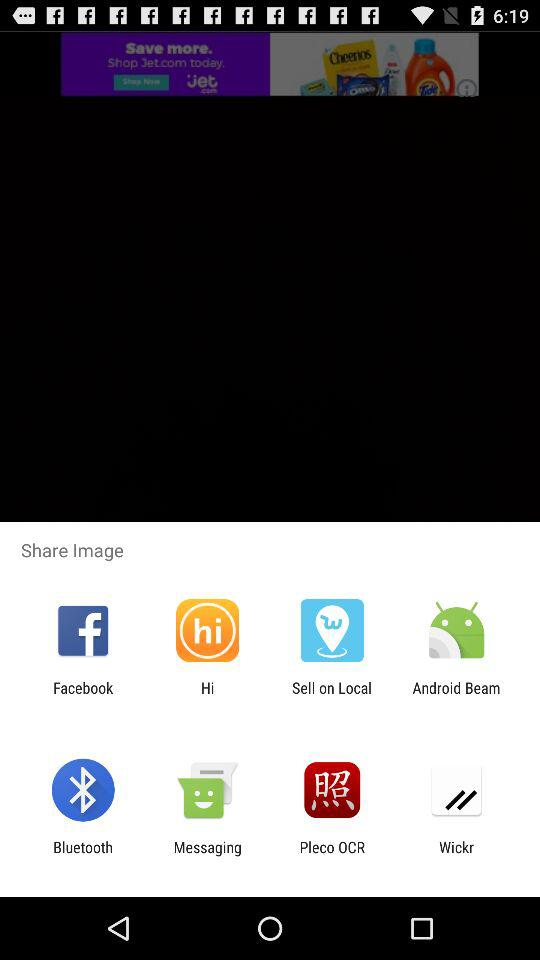How many images are being shared?
When the provided information is insufficient, respond with <no answer>. <no answer> 